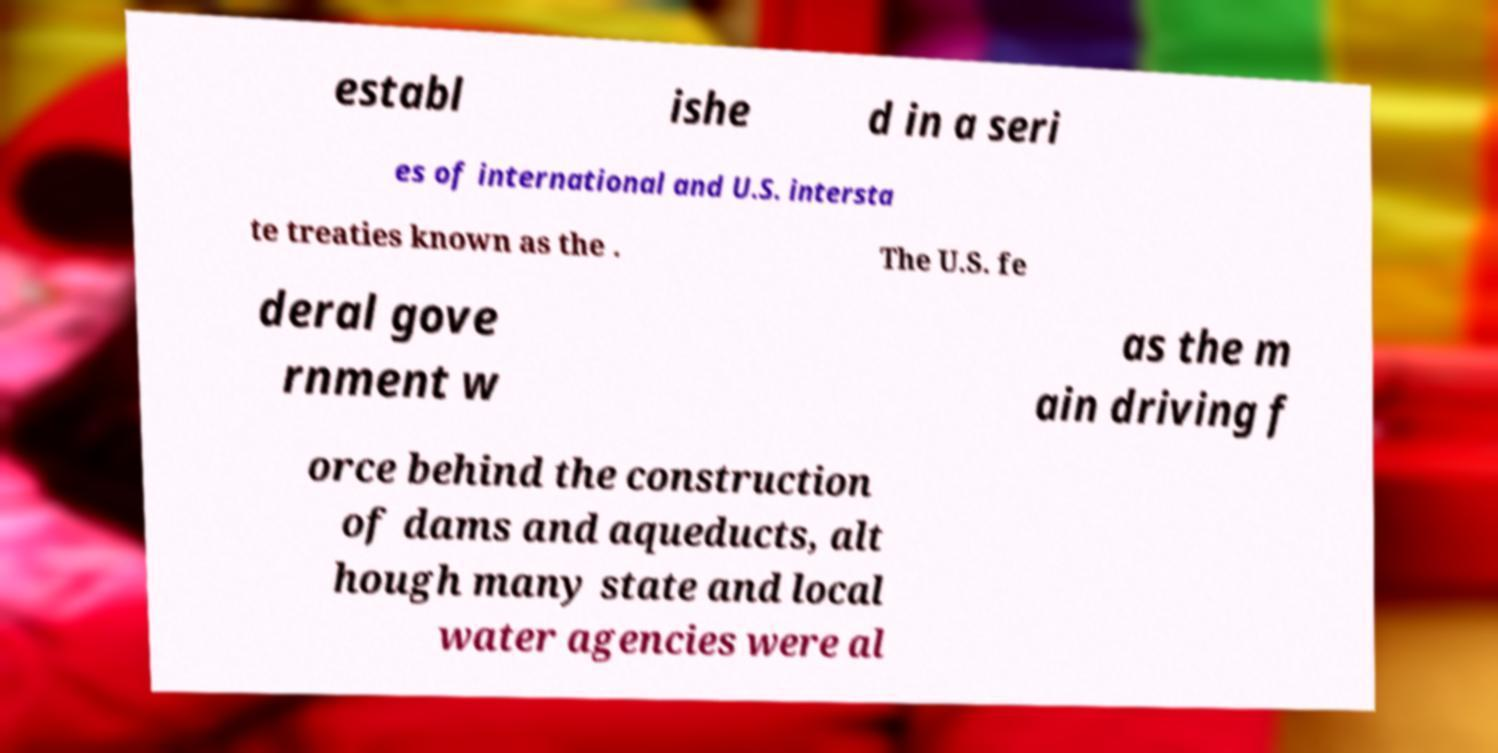Can you read and provide the text displayed in the image?This photo seems to have some interesting text. Can you extract and type it out for me? establ ishe d in a seri es of international and U.S. intersta te treaties known as the . The U.S. fe deral gove rnment w as the m ain driving f orce behind the construction of dams and aqueducts, alt hough many state and local water agencies were al 